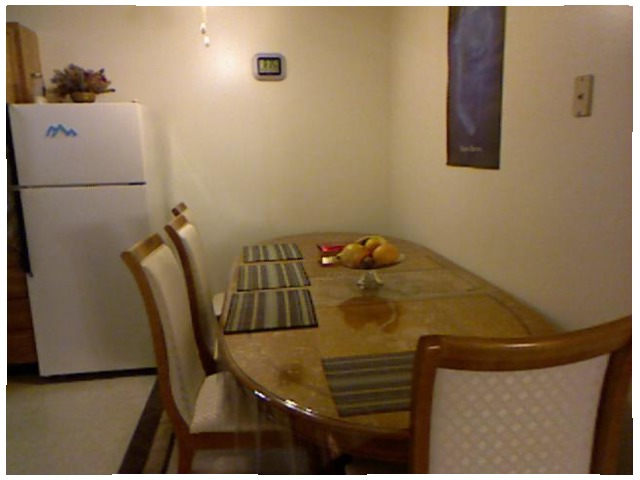<image>
Is there a fruit on the table? Yes. Looking at the image, I can see the fruit is positioned on top of the table, with the table providing support. Is the chair on the table? No. The chair is not positioned on the table. They may be near each other, but the chair is not supported by or resting on top of the table. Is the chairs on the table? No. The chairs is not positioned on the table. They may be near each other, but the chairs is not supported by or resting on top of the table. Where is the lemon in relation to the chair? Is it on the chair? No. The lemon is not positioned on the chair. They may be near each other, but the lemon is not supported by or resting on top of the chair. Is there a table on the wall? No. The table is not positioned on the wall. They may be near each other, but the table is not supported by or resting on top of the wall. 